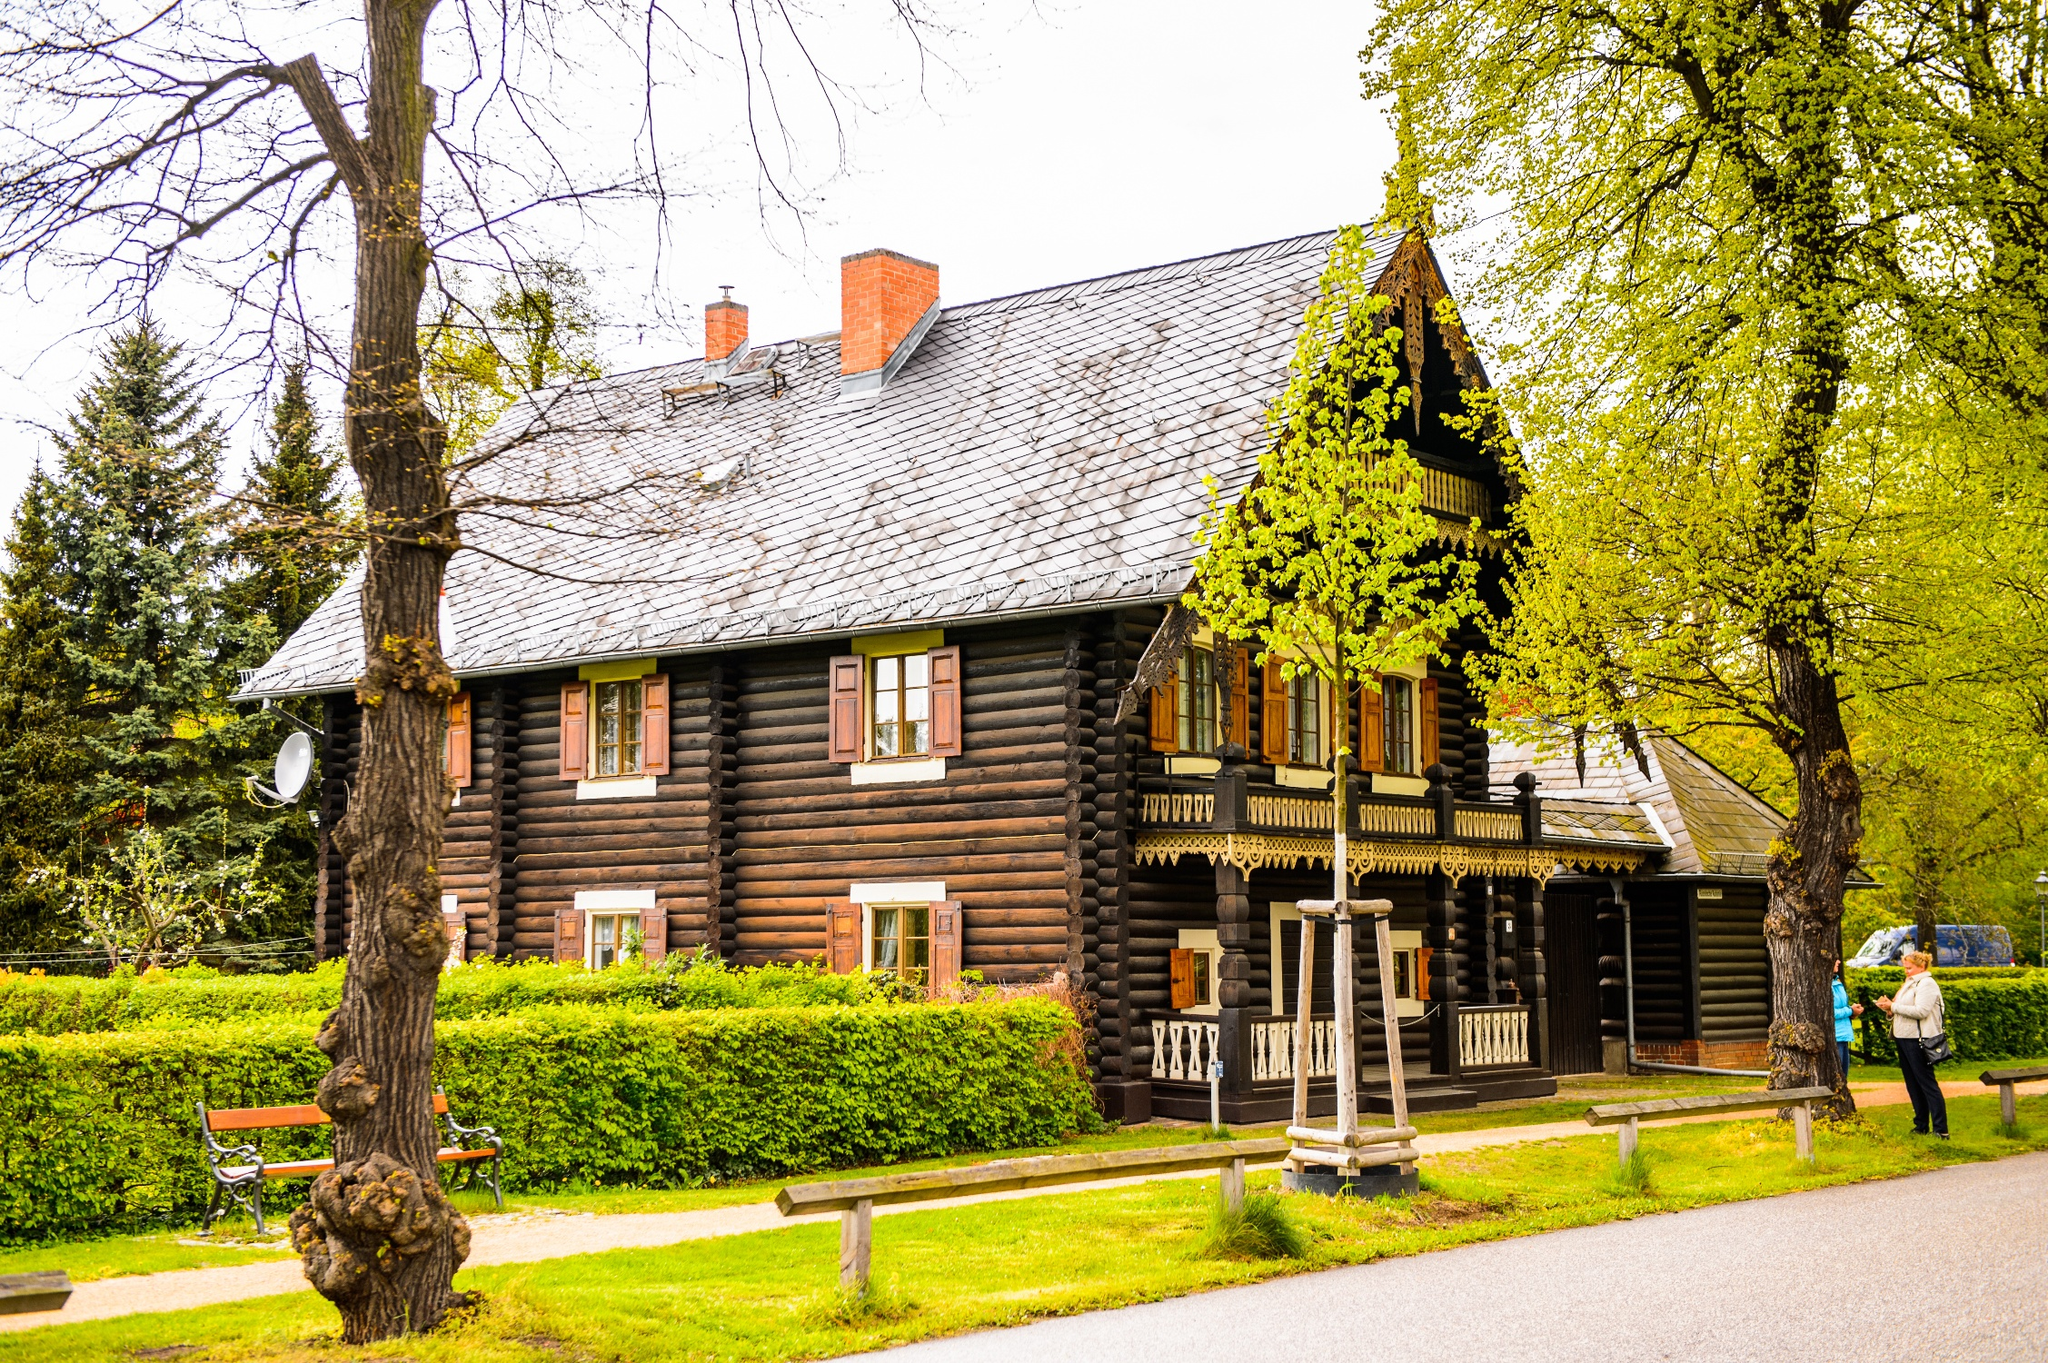What historical era might this cabin represent, and are there any architectural features that are particularly characteristic of that time? This cabin is indicative of a 19th-century rural American or European style, commonly seen in areas where log construction was favored due to the availability of timber. Key architectural features include the log construction itself, evident in the exposed rounded logs with chinking between them, and the ornate wooden carvings on the gables and porch, which add a decorative touch typical of the folk architecture from that period. The presence of a large chimney also suggests a reliance on wood heating, another characteristic of homes from this era. 